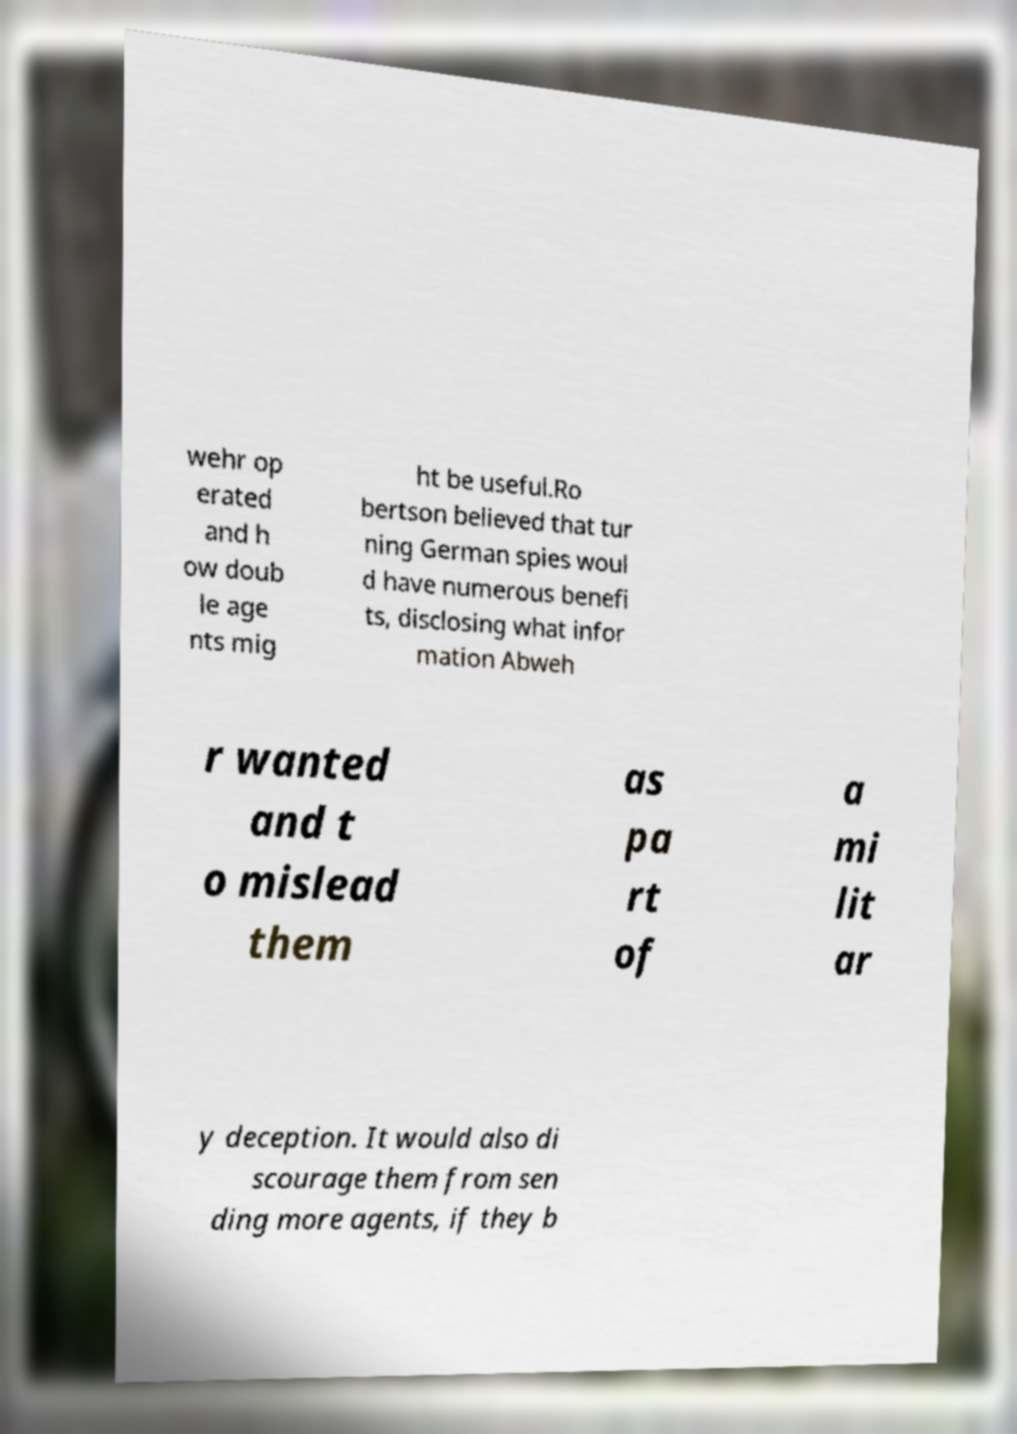There's text embedded in this image that I need extracted. Can you transcribe it verbatim? wehr op erated and h ow doub le age nts mig ht be useful.Ro bertson believed that tur ning German spies woul d have numerous benefi ts, disclosing what infor mation Abweh r wanted and t o mislead them as pa rt of a mi lit ar y deception. It would also di scourage them from sen ding more agents, if they b 